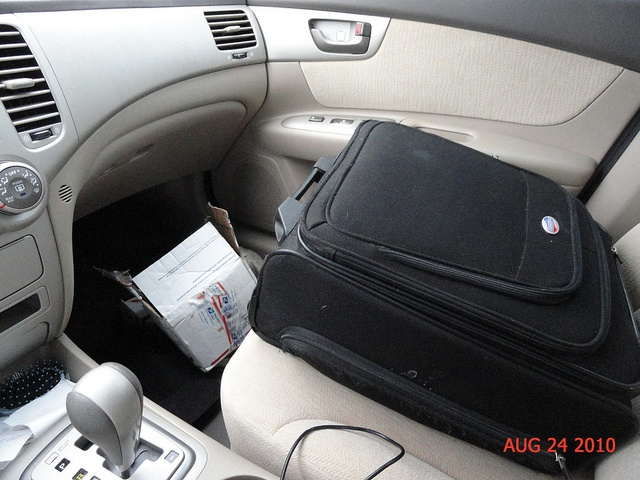Describe the objects in this image and their specific colors. I can see a suitcase in white, black, and gray tones in this image. 